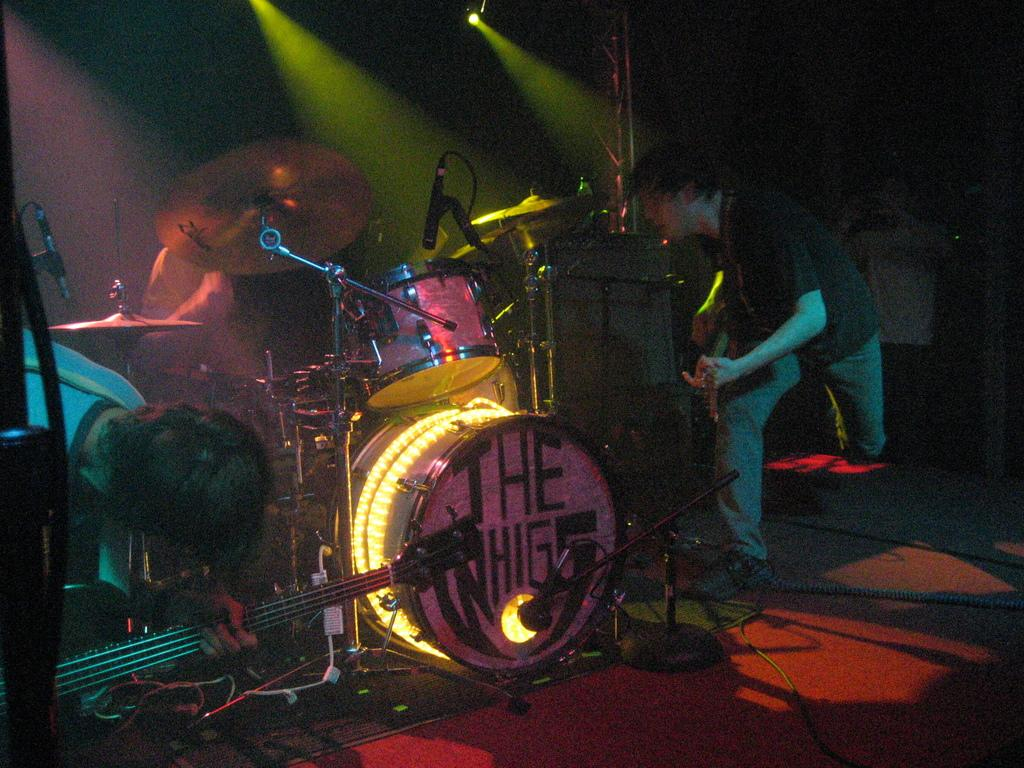How many people are in the image? There are persons in the image, but the exact number is not specified. What are the persons wearing? The persons are wearing clothes. What are the persons doing in the image? The persons are playing musical instruments. What type of musical instrument can be seen in the middle of the image? There are musical drums in the middle of the image. What is the source of light in the image? There is a light at the top of the image. What is on the list that the persons are thinking about in the image? There is no list or indication of thoughts in the image; the persons are playing musical instruments. 